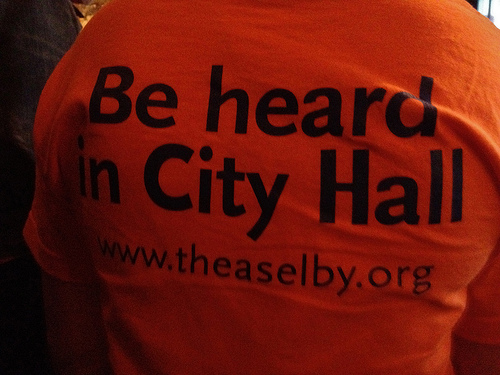<image>
Can you confirm if the be is behind the org? No. The be is not behind the org. From this viewpoint, the be appears to be positioned elsewhere in the scene. 